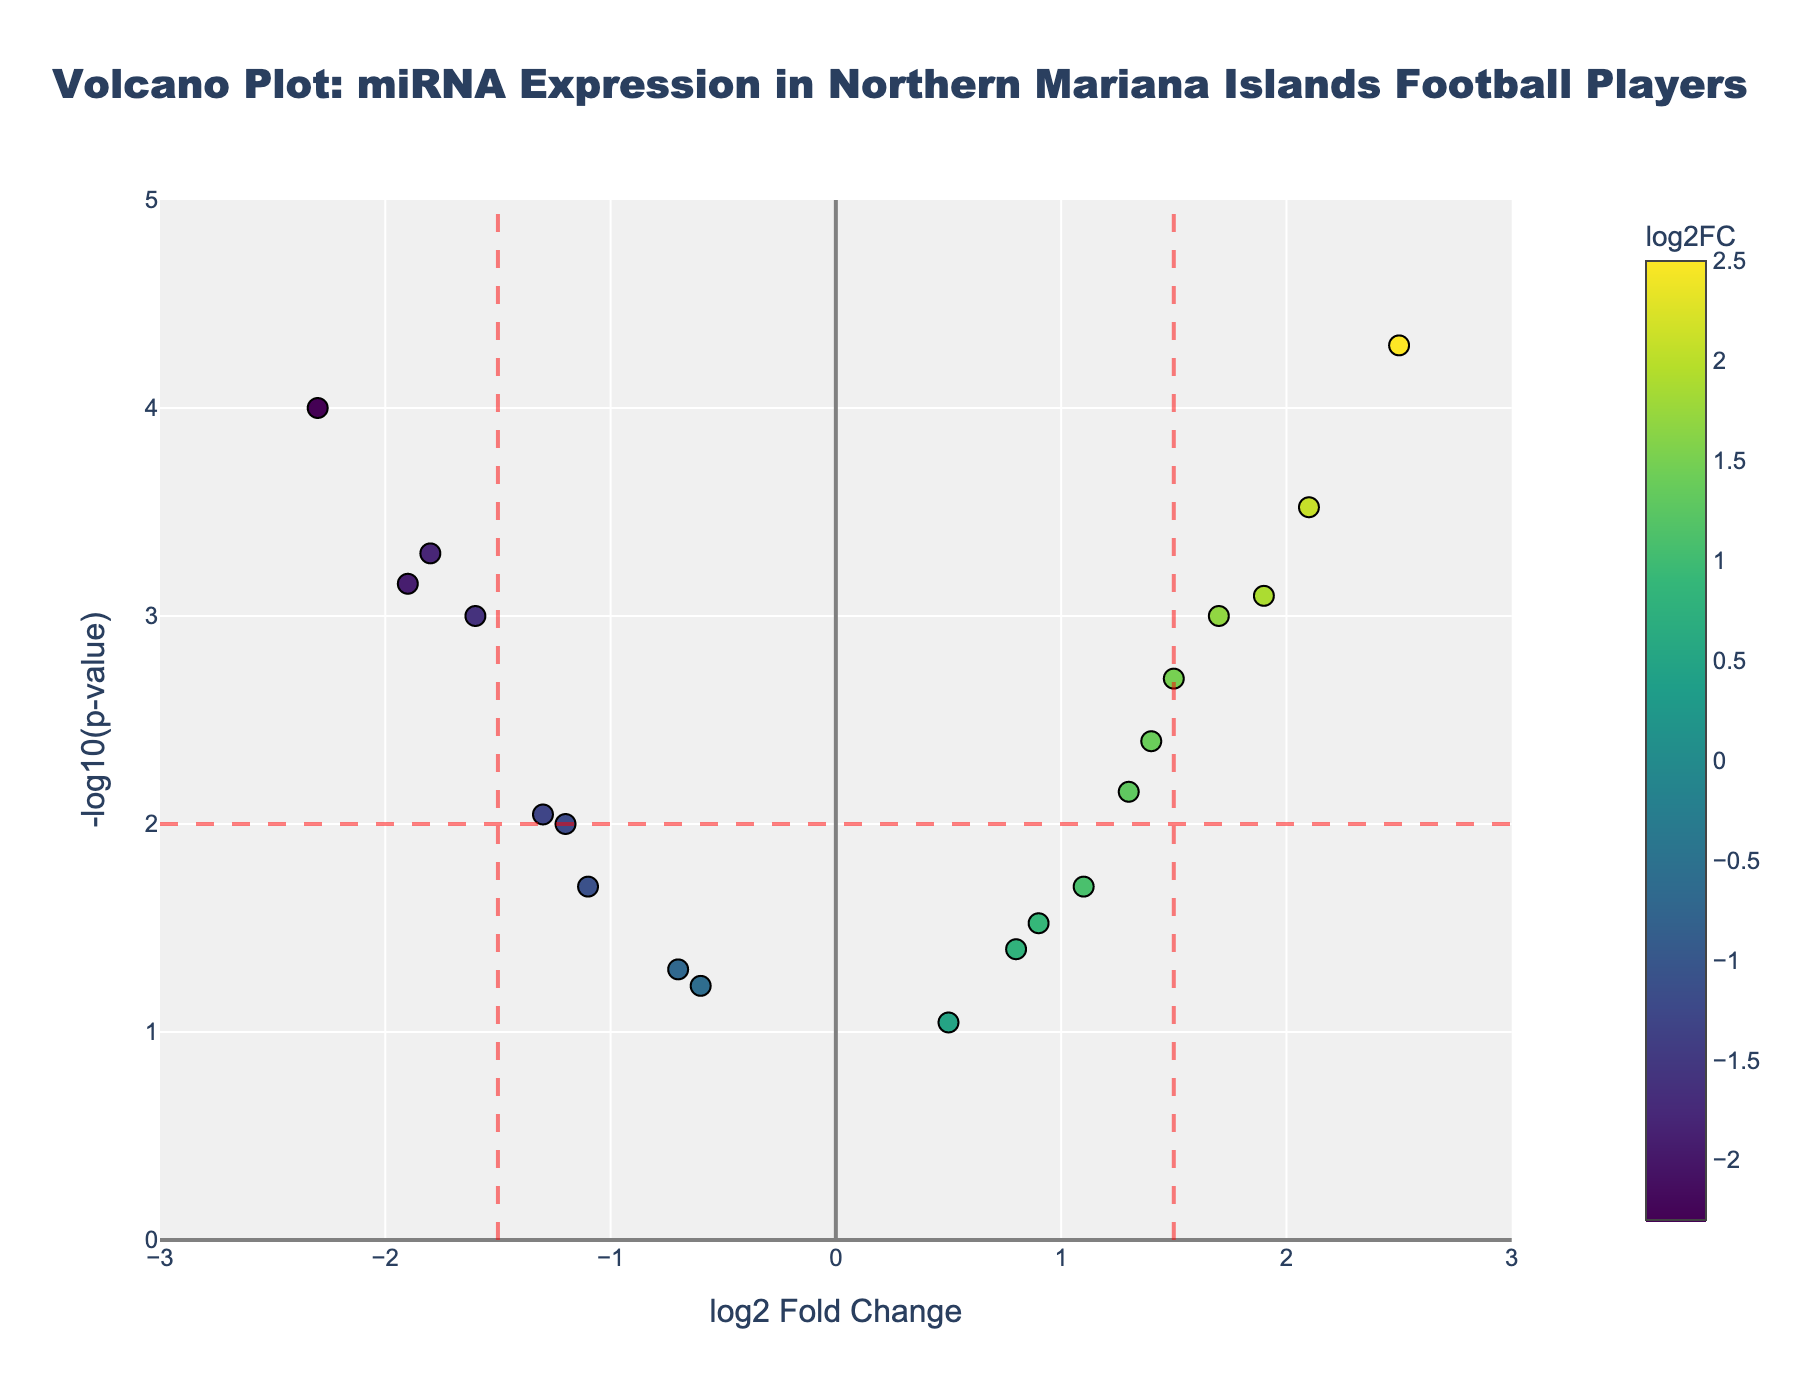What's the title of the figure? The title is placed at the top of the figure, which introduces the plot and helps to understand its context.
Answer: Volcano Plot: miRNA Expression in Northern Mariana Islands Football Players What does the x-axis represent in the plot? The x-axis title should clearly indicate the data it represents. Here, it reads 'log2 Fold Change,' which shows the changes in expression levels of miRNAs.
Answer: log2 Fold Change What is depicted on the y-axis of the plot? The y-axis in a Volcano Plot typically represents the statistical significance of the data points. In this figure, it shows '-log10(p-value),' indicating the significance of the miRNA expression changes.
Answer: -log10(p-value) Which miRNA has the highest log2 Fold Change? By scanning the x-axis values, the miRNA with the highest value on the positive side represents the highest log2 Fold Change. The highest point on the right is miR-378.
Answer: miR-378 Which miRNA has the smallest p-value? The miRNA with the smallest p-value will have the highest -log10(p-value) value on the y-axis. The highest point vertically belongs to miR-378.
Answer: miR-378 Identify the miRNAs that are significantly upregulated (log2 Fold Change > 1.5 and p-value < 0.01). To identify significantly upregulated miRNAs, we look for miRNAs with log2 Fold Change greater than 1.5 and -log10(p-value) higher than -log10(0.01). miR-378 and miR-486 meet these criteria.
Answer: miR-378, miR-486 How many miRNAs have a log2 Fold Change greater than 1.5? Count the data points on the x-axis that fall to the right of the 1.5 line. These are miR-133a and miR-21.
Answer: 2 Compare miR-29b and miR-10b: which one has a lower p-value? By comparing the vertical positions of miR-29b and miR-10b, the miRNA with the higher y-axis value (greater -log10(p-value)) has a lower p-value. miR-29b is higher.
Answer: miR-29b What is the log2 Fold Change of miR-143 and is it considered significant? Locate the data point for miR-143 on the x-axis. miR-143 has a log2 Fold Change of 1.7, which is greater than the 1.5 threshold, and its p-value is less than 0.01, making it significant.
Answer: 1.7, Yes 